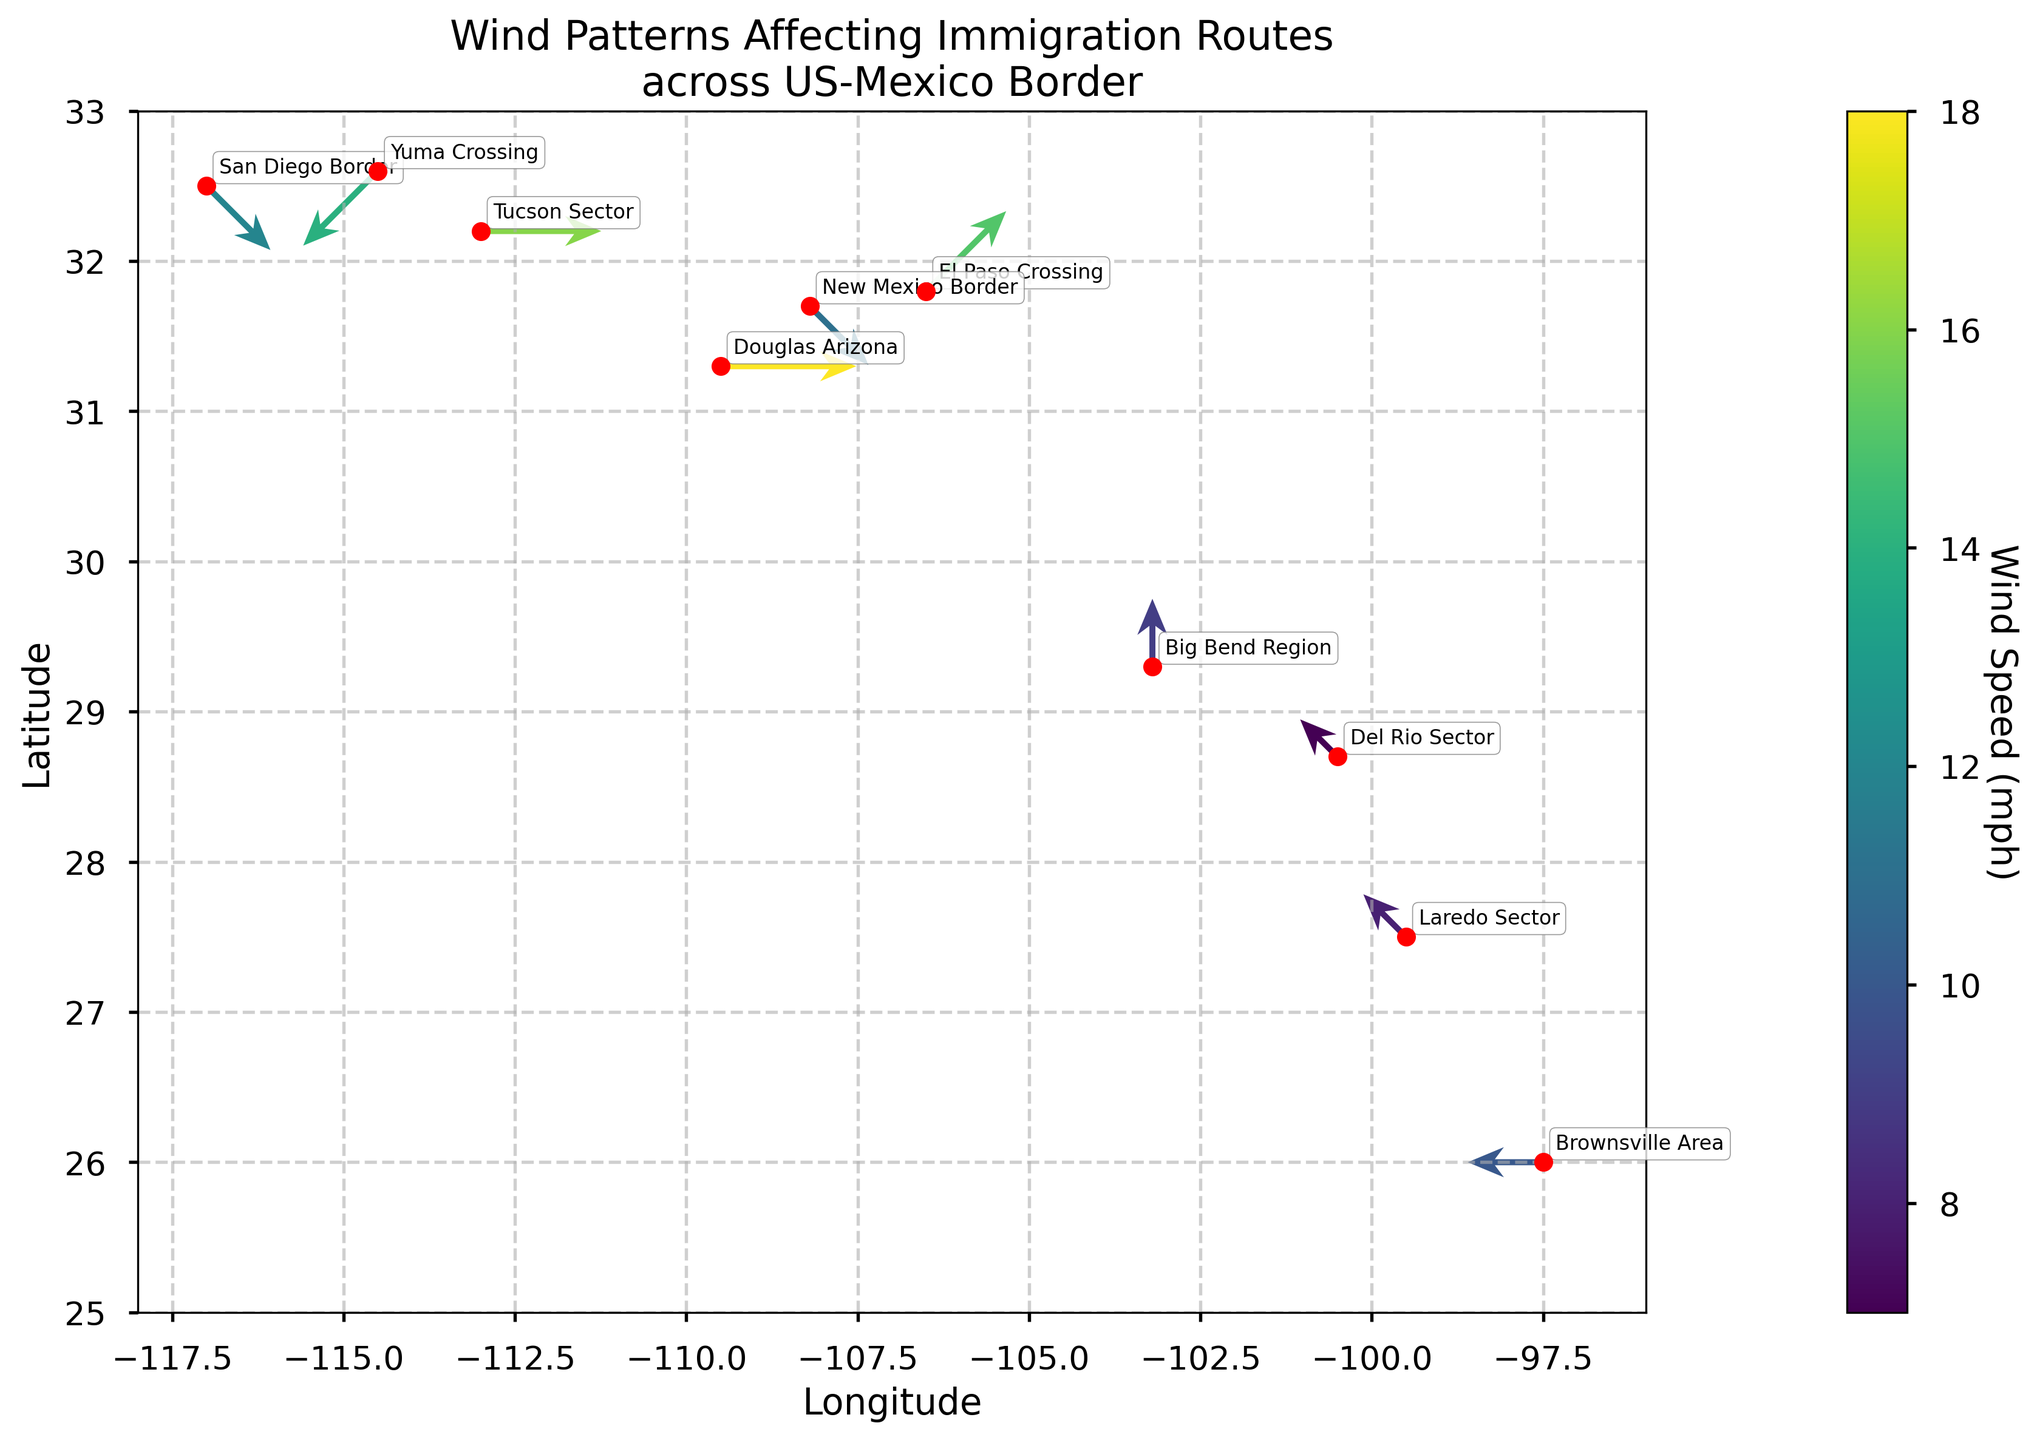What is the wind direction at the San Diego Border? The wind direction is marked on the figure by the vector's angle. For the San Diego Border, the vector points northwest (NW).
Answer: NW What is the highest wind speed recorded, and where does it occur? The wind speed is indicated by the color of the vectors, cross-referenced with the color bar. The highest wind speed is 18 mph, which occurs at Douglas Arizona.
Answer: 18 mph at Douglas Arizona How many locations have wind speeds less than 10 mph? By examining the colors of the vectors associated with each location and cross-referencing them with the color bar, three locations have wind speeds less than 10 mph (Laredo Sector, Big Bend Region, Del Rio Sector).
Answer: 3 locations What is the average wind speed across all locations? Sum all wind speeds and divide by the number of locations. (12 + 15 + 8 + 10 + 18 + 14 + 9 + 11 + 7 + 16) / 10 = 12 mph.
Answer: 12 mph Which location has the wind blowing from the northeast, and what is the speed? The wind direction for northeast (NE) is noted on the vector angles, plotted towards 45 degrees from the north. Yuma Crossing has the wind blowing from the northeast at 14 mph.
Answer: Yuma Crossing at 14 mph What is the predominant wind direction in the Tucson Sector? Look at the vector angle for Tucson Sector. It points to the west, indicating the wind direction is west (W).
Answer: W Compare the wind speeds between El Paso Crossing and New Mexico Border. Which one is higher? Evaluate the speeds indicated for both locations: El Paso Crossing is 15 mph, and New Mexico Border is 11 mph. Thus, El Paso Crossing has the higher wind speed.
Answer: El Paso Crossing What are the coordinates of the location with the lowest wind speed? Reference the wind speeds and find the lowest one (7 mph at Del Rio Sector) and note its coordinates (28.7, -100.5).
Answer: 28.7, -100.5 Which location has its wind direction directly opposite to the San Diego Border's wind direction? San Diego Border has NW wind (315 degrees). The opposite direction is SE (135 degrees), which matches Del Rio Sector.
Answer: Del Rio Sector What is the total number of locations evaluated on the map? Count the locations listed in the figure which represents 10 unique locations.
Answer: 10 